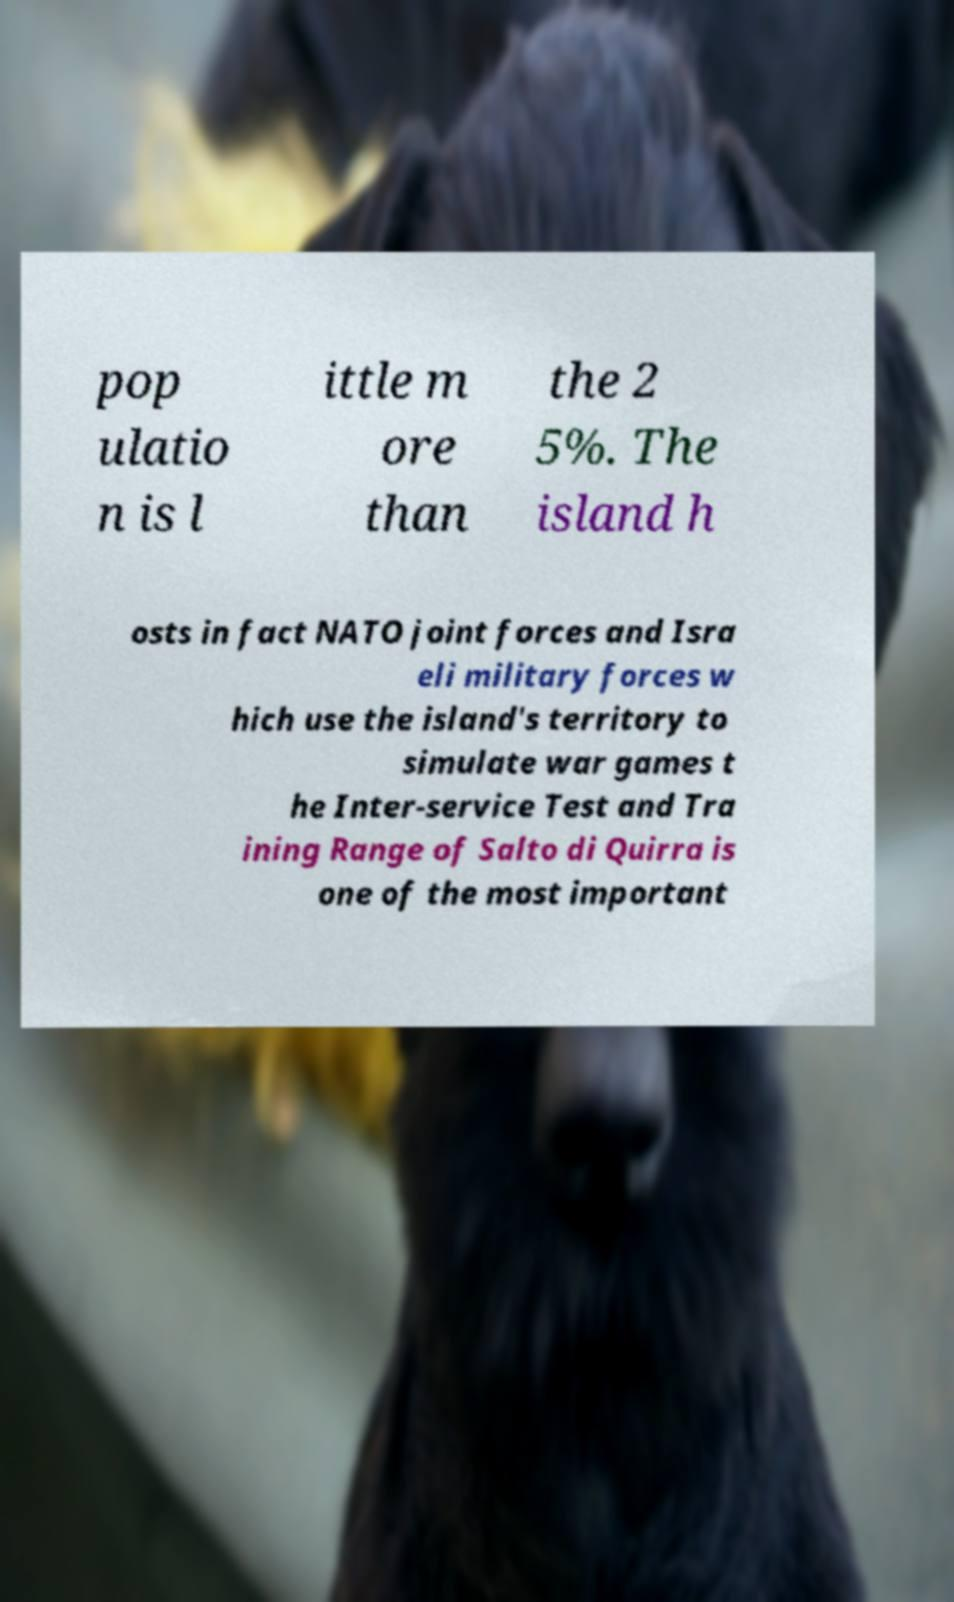What messages or text are displayed in this image? I need them in a readable, typed format. pop ulatio n is l ittle m ore than the 2 5%. The island h osts in fact NATO joint forces and Isra eli military forces w hich use the island's territory to simulate war games t he Inter-service Test and Tra ining Range of Salto di Quirra is one of the most important 